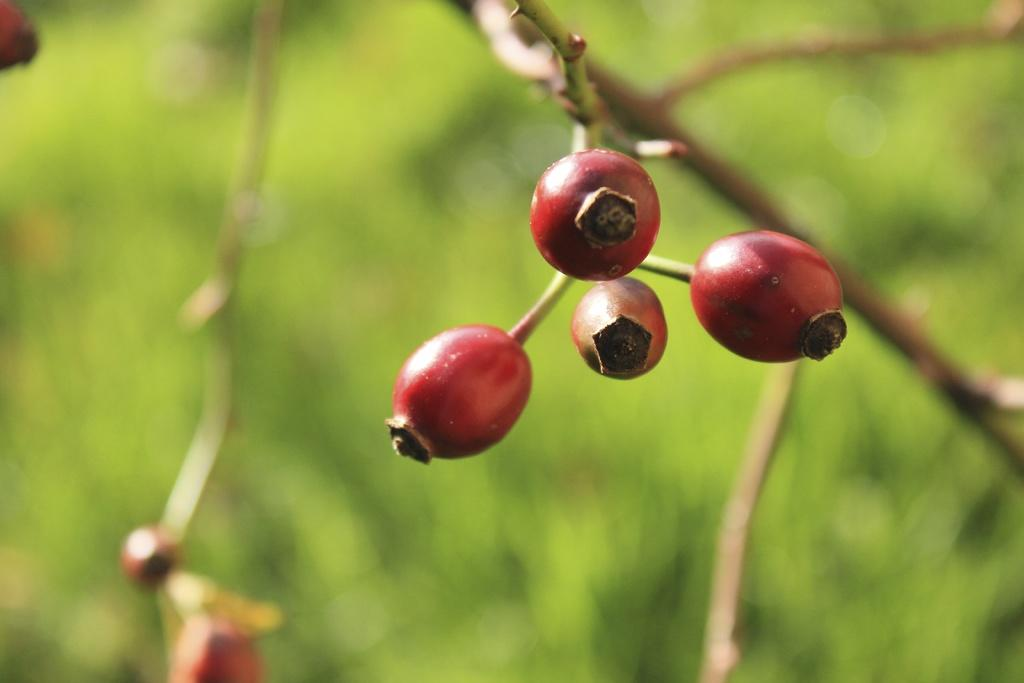What color are the fruits in the image? The fruits in the image are red. How are the fruits connected to each other? The fruits are attached to a stem. Can you describe the background of the image? The backdrop of the image is blurred. What type of vase is holding the lumber in the image? There is no vase or lumber present in the image; it only features red color fruits attached to a stem. 